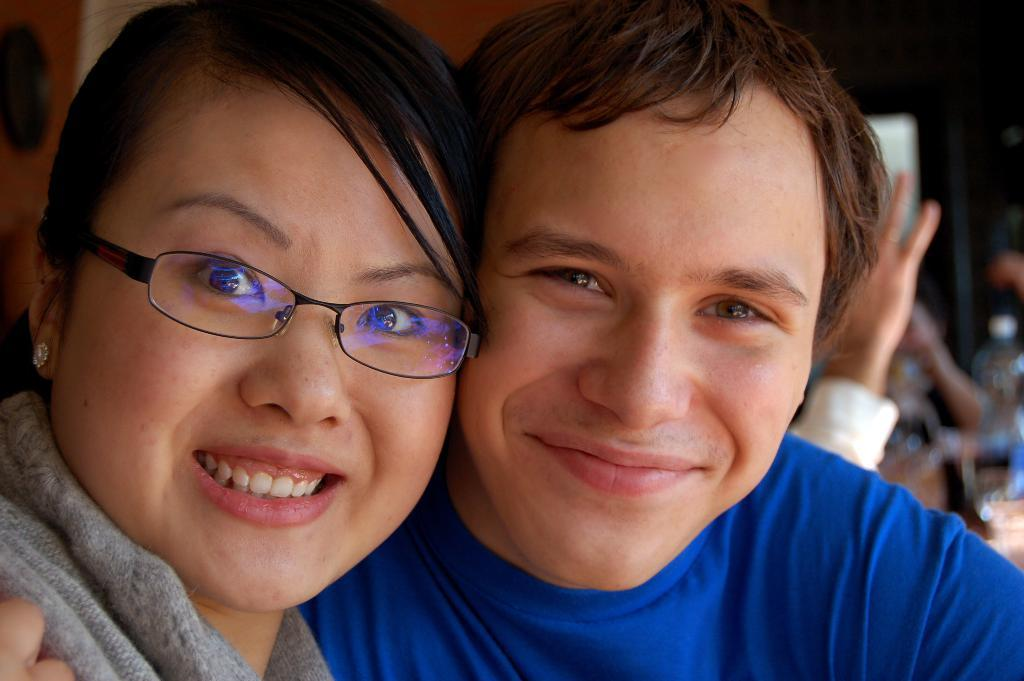Who are the people in the foreground of the image? There is a man and a woman in the foreground of the image. Can you describe the background of the image? There are few persons visible in the background of the image, and there is a wall in the background. What is located on the right side of the image? There are objects on the right side of the image. What type of fiction can be seen on the library shelves in the image? There is no library or fiction books present in the image. 